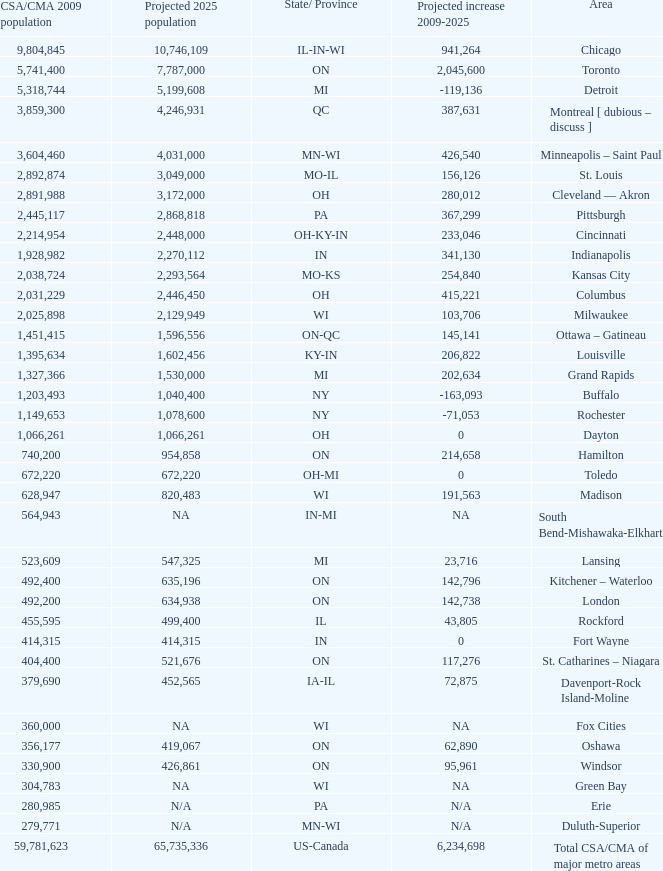What's the projected population of IN-MI? NA. 